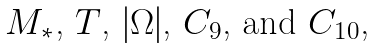<formula> <loc_0><loc_0><loc_500><loc_500>\text {$ M_{*} $,   $ T $, $ |\Omega| $, $C_{9}$, and $C_{10} $,}</formula> 